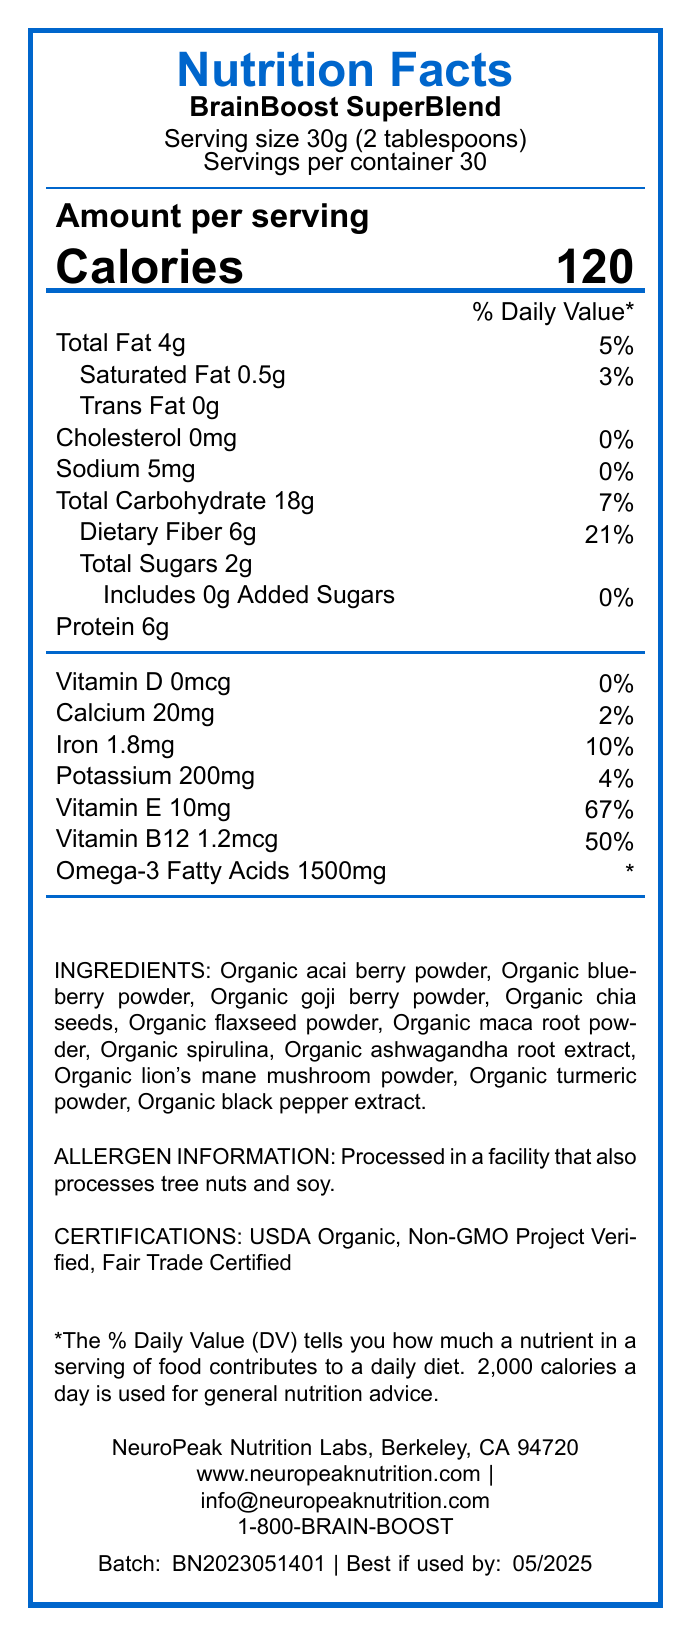what is the serving size of BrainBoost SuperBlend? The serving size is explicitly mentioned as "30g (2 tablespoons)".
Answer: 30g (2 tablespoons) How many calories are in one serving of BrainBoost SuperBlend? The document states that there are 120 calories per serving.
Answer: 120 What is the daily value percentage for dietary fiber in one serving? The daily value percentage for dietary fiber is listed as 21%.
Answer: 21% How much protein is in one serving? The document shows that there are 6 grams of protein in one serving.
Answer: 6g Does BrainBoost SuperBlend contain any trans fat? The document lists the amount of trans fat as 0g.
Answer: No How many servings are there per container of BrainBoost SuperBlend? It is mentioned that there are 30 servings per container.
Answer: 30 Which of the following vitamins is present in the highest daily value percentage in BrainBoost SuperBlend? A. Vitamin D B. Calcium C. Iron D. Vitamin E Vitamin E has the highest daily value percentage at 67%.
Answer: D What is the total amount of iron in one serving of BrainBoost SuperBlend? The document states that one serving contains 1.8mg of iron.
Answer: 1.8mg Which ingredient is not present in BrainBoost SuperBlend? A. Organic turmeric powder B. Organic spinach powder C. Organic goji berry powder The blend does not contain Organic spinach powder; all other ingredients are listed.
Answer: B Are there any added sugars in BrainBoost SuperBlend? The document explicitly states that there are 0g of added sugars.
Answer: No Does the document provide any information on certifications related to BrainBoost SuperBlend? It mentions "USDA Organic, Non-GMO Project Verified, Fair Trade Certified".
Answer: Yes Is the blend processed in a facility that also handles tree nuts and soy? The allergen information notes that it is processed in a facility that also processes tree nuts and soy.
Answer: Yes How much Omega-3 fatty acids are present in a serving according to the document? The document lists 1500mg of Omega-3 fatty acids per serving.
Answer: 1500mg What is the sustainability statement mentioned in the document? The document includes a sustainability statement noting the sourcing and packaging practices.
Answer: Sourced from small-scale organic farms using regenerative agriculture practices. Packaging made from 100% post-consumer recycled materials. Can the document confirm that the product is free from all allergens? The document indicates it is processed in a facility that handles tree nuts and soy, thus it cannot confirm it is free from all allergens.
Answer: No Summarize the main idea of the BrainBoost SuperBlend Nutrition Facts Label. The document gives an overview of the product's nutritional information, ingredient list, allergen notice, certifications, sustainability practices, and other relevant details.
Answer: The label provides a comprehensive breakdown of the nutritional content, ingredients, and certifications of the BrainBoost SuperBlend. It highlights per-serving amounts of key nutrients and vitamins, notes the presence or absence of specific fats, sugars, and cholesterol, and lists potential allergens. It also includes information on sustainability practices, usage instructions, and contact details for the manufacturer. What are the neuroscience research institutions mentioned in the BrainBoost SuperBlend formulation? The document mentions the formulation based on studies from leading institutions but does not specify the institutions by name.
Answer: Cannot be determined 